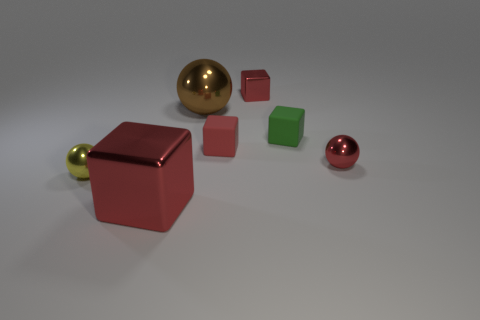There is a large shiny thing behind the small yellow metal object; does it have the same shape as the red thing in front of the yellow sphere?
Your answer should be compact. No. What color is the big cube that is made of the same material as the brown object?
Your answer should be very brief. Red. Is the number of tiny red matte things that are left of the large sphere less than the number of yellow spheres?
Your answer should be very brief. Yes. What is the size of the metal object to the right of the green cube behind the tiny ball that is on the left side of the tiny red ball?
Offer a very short reply. Small. Do the red thing in front of the yellow sphere and the yellow object have the same material?
Provide a succinct answer. Yes. What is the material of the tiny ball that is the same color as the large cube?
Make the answer very short. Metal. How many things are either metal things or brown metal balls?
Provide a short and direct response. 5. There is a brown shiny thing that is the same shape as the small yellow metallic thing; what is its size?
Your response must be concise. Large. What number of other things are the same color as the small metallic block?
Offer a very short reply. 3. How many cubes are yellow things or tiny things?
Your answer should be very brief. 3. 